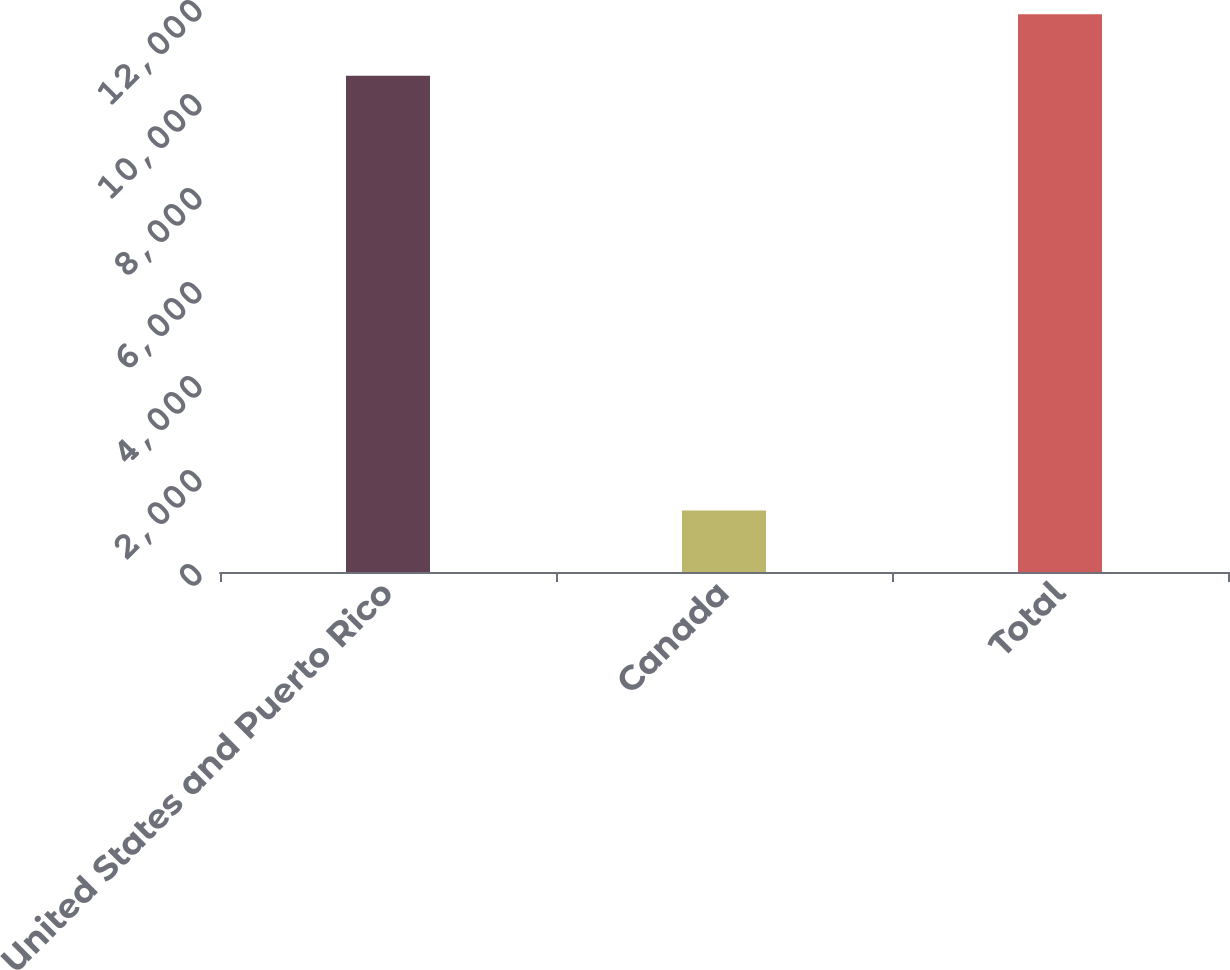Convert chart. <chart><loc_0><loc_0><loc_500><loc_500><bar_chart><fcel>United States and Puerto Rico<fcel>Canada<fcel>Total<nl><fcel>10558<fcel>1310<fcel>11868<nl></chart> 